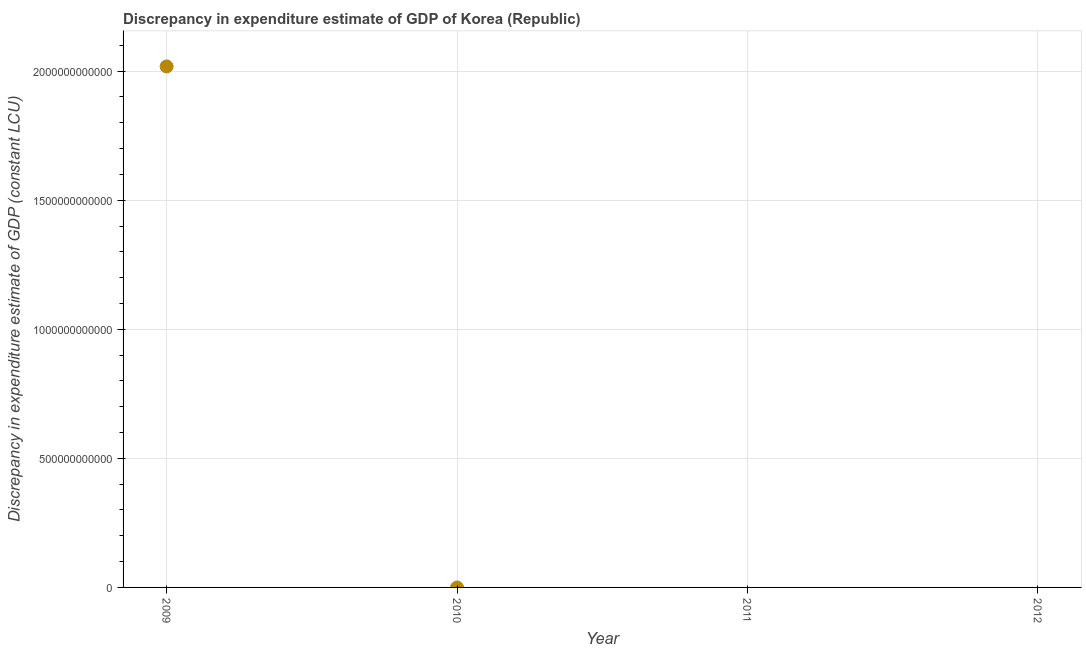What is the discrepancy in expenditure estimate of gdp in 2009?
Give a very brief answer. 2.02e+12. Across all years, what is the maximum discrepancy in expenditure estimate of gdp?
Your response must be concise. 2.02e+12. In which year was the discrepancy in expenditure estimate of gdp maximum?
Your answer should be compact. 2009. What is the sum of the discrepancy in expenditure estimate of gdp?
Offer a very short reply. 2.02e+12. What is the average discrepancy in expenditure estimate of gdp per year?
Provide a short and direct response. 5.05e+11. What is the median discrepancy in expenditure estimate of gdp?
Keep it short and to the point. 0. What is the difference between the highest and the lowest discrepancy in expenditure estimate of gdp?
Your answer should be compact. 2.02e+12. What is the difference between two consecutive major ticks on the Y-axis?
Keep it short and to the point. 5.00e+11. Does the graph contain any zero values?
Keep it short and to the point. Yes. What is the title of the graph?
Your answer should be compact. Discrepancy in expenditure estimate of GDP of Korea (Republic). What is the label or title of the X-axis?
Your answer should be compact. Year. What is the label or title of the Y-axis?
Your answer should be compact. Discrepancy in expenditure estimate of GDP (constant LCU). What is the Discrepancy in expenditure estimate of GDP (constant LCU) in 2009?
Offer a very short reply. 2.02e+12. What is the Discrepancy in expenditure estimate of GDP (constant LCU) in 2012?
Your answer should be very brief. 0. 